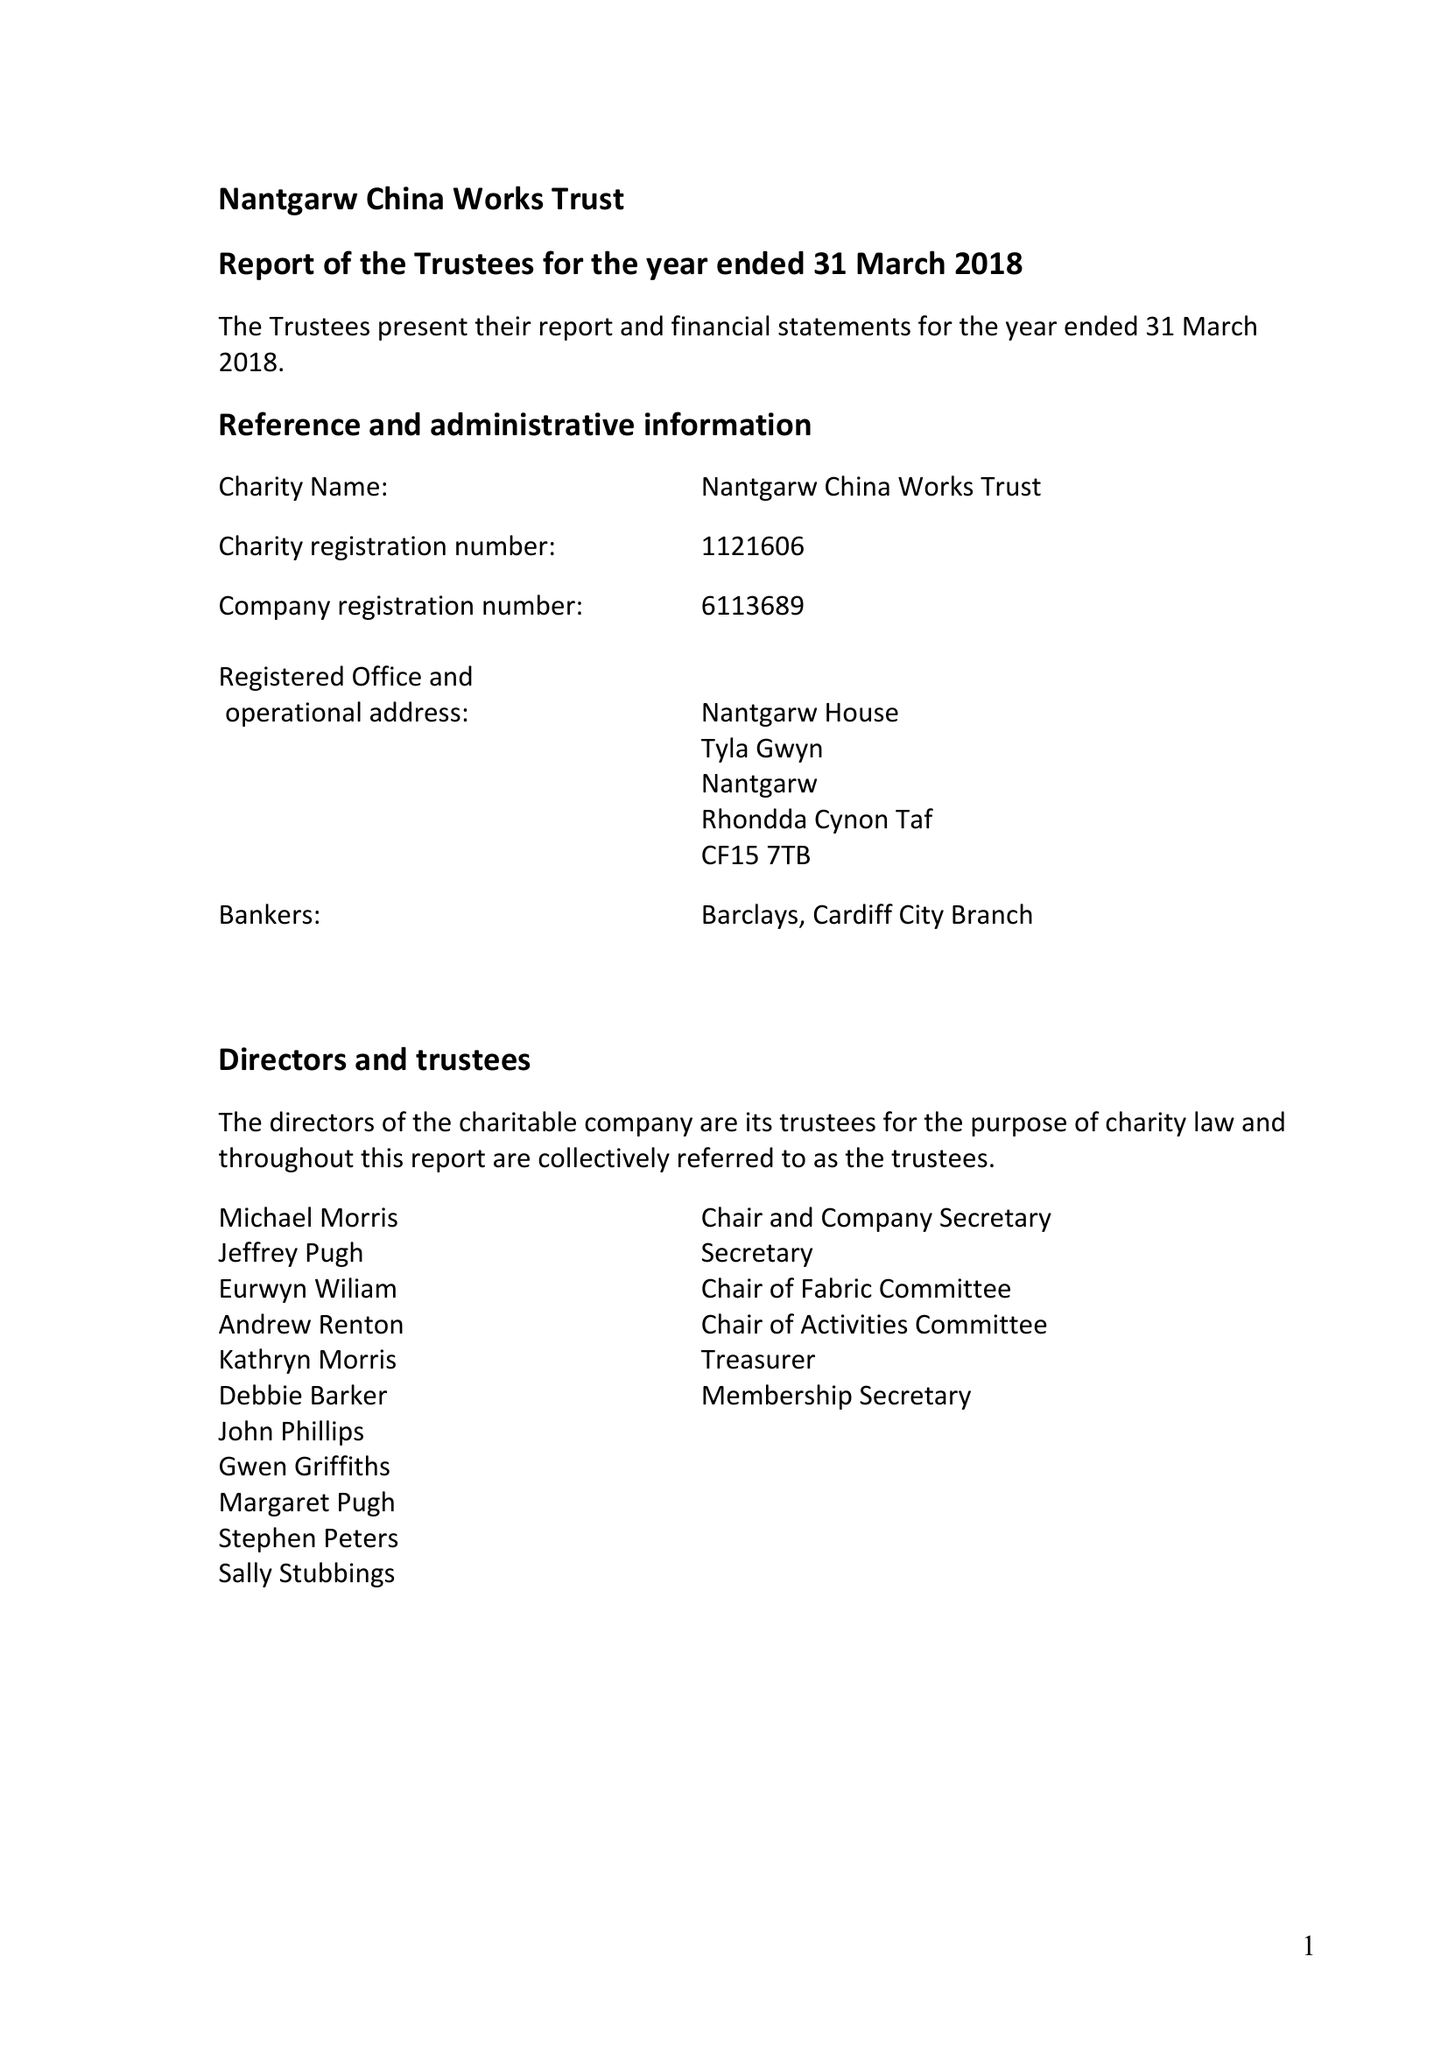What is the value for the charity_number?
Answer the question using a single word or phrase. 1121606 